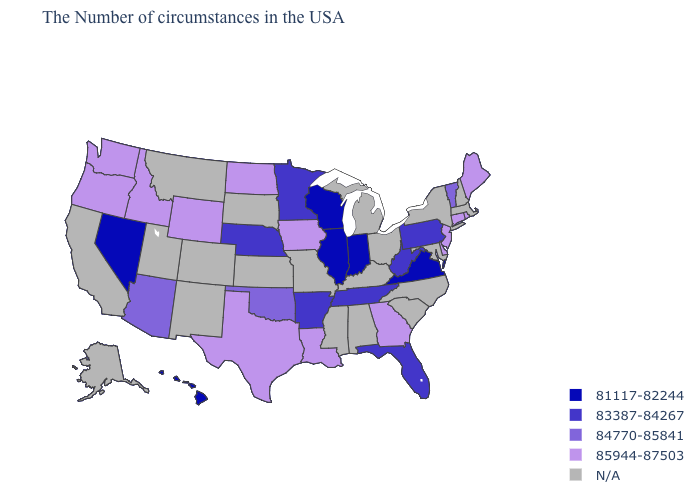Among the states that border Rhode Island , which have the highest value?
Be succinct. Connecticut. What is the value of Nebraska?
Write a very short answer. 83387-84267. Which states hav the highest value in the South?
Keep it brief. Delaware, Georgia, Louisiana, Texas. Name the states that have a value in the range 84770-85841?
Short answer required. Vermont, Oklahoma, Arizona. Is the legend a continuous bar?
Write a very short answer. No. Does Wyoming have the highest value in the USA?
Give a very brief answer. Yes. Which states have the lowest value in the MidWest?
Answer briefly. Indiana, Wisconsin, Illinois. What is the lowest value in the MidWest?
Short answer required. 81117-82244. What is the value of Louisiana?
Give a very brief answer. 85944-87503. Does Pennsylvania have the lowest value in the Northeast?
Answer briefly. Yes. Which states hav the highest value in the Northeast?
Give a very brief answer. Maine, Rhode Island, Connecticut, New Jersey. Name the states that have a value in the range 81117-82244?
Concise answer only. Virginia, Indiana, Wisconsin, Illinois, Nevada, Hawaii. What is the value of Iowa?
Short answer required. 85944-87503. Name the states that have a value in the range 81117-82244?
Short answer required. Virginia, Indiana, Wisconsin, Illinois, Nevada, Hawaii. Name the states that have a value in the range N/A?
Keep it brief. Massachusetts, New Hampshire, New York, Maryland, North Carolina, South Carolina, Ohio, Michigan, Kentucky, Alabama, Mississippi, Missouri, Kansas, South Dakota, Colorado, New Mexico, Utah, Montana, California, Alaska. 